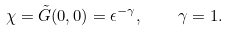Convert formula to latex. <formula><loc_0><loc_0><loc_500><loc_500>\chi = \tilde { G } ( 0 , 0 ) = \epsilon ^ { - \gamma } , \quad \gamma = 1 .</formula> 